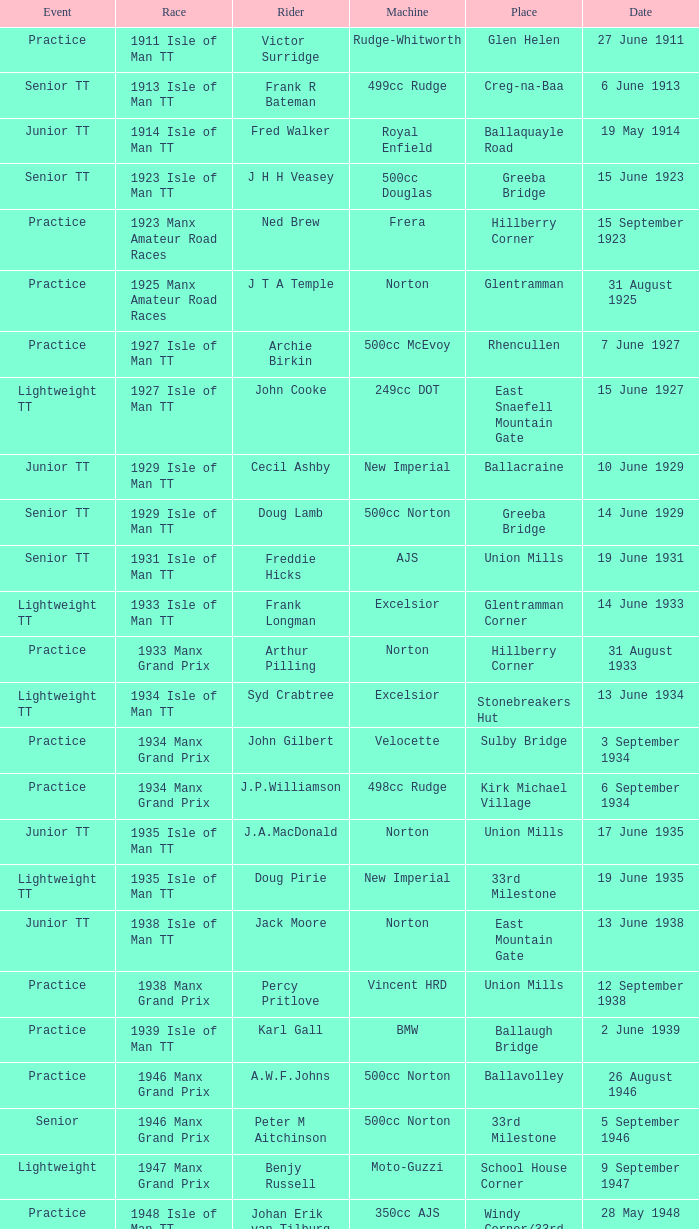What event was Rob Vine riding? Senior TT. 